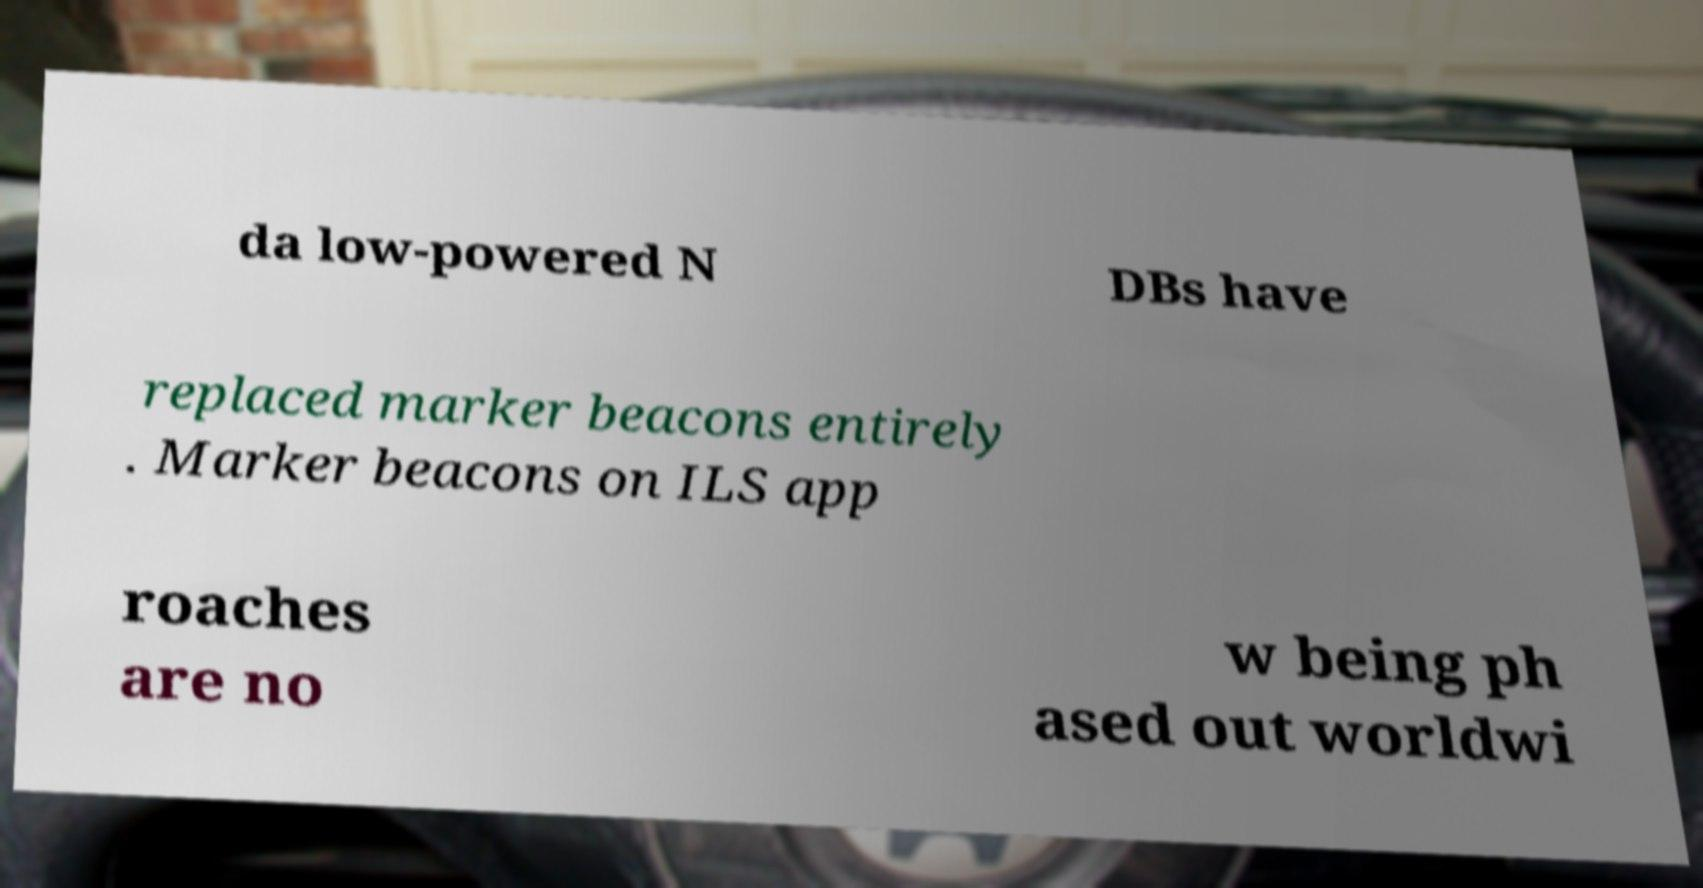What messages or text are displayed in this image? I need them in a readable, typed format. da low-powered N DBs have replaced marker beacons entirely . Marker beacons on ILS app roaches are no w being ph ased out worldwi 